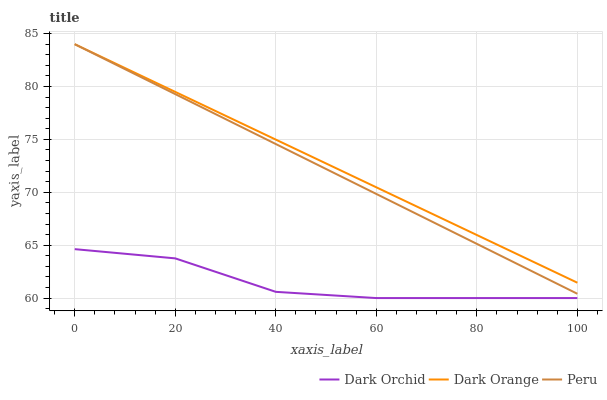Does Dark Orchid have the minimum area under the curve?
Answer yes or no. Yes. Does Dark Orange have the maximum area under the curve?
Answer yes or no. Yes. Does Peru have the minimum area under the curve?
Answer yes or no. No. Does Peru have the maximum area under the curve?
Answer yes or no. No. Is Dark Orange the smoothest?
Answer yes or no. Yes. Is Dark Orchid the roughest?
Answer yes or no. Yes. Is Peru the smoothest?
Answer yes or no. No. Is Peru the roughest?
Answer yes or no. No. Does Dark Orchid have the lowest value?
Answer yes or no. Yes. Does Peru have the lowest value?
Answer yes or no. No. Does Peru have the highest value?
Answer yes or no. Yes. Does Dark Orchid have the highest value?
Answer yes or no. No. Is Dark Orchid less than Peru?
Answer yes or no. Yes. Is Peru greater than Dark Orchid?
Answer yes or no. Yes. Does Dark Orange intersect Peru?
Answer yes or no. Yes. Is Dark Orange less than Peru?
Answer yes or no. No. Is Dark Orange greater than Peru?
Answer yes or no. No. Does Dark Orchid intersect Peru?
Answer yes or no. No. 